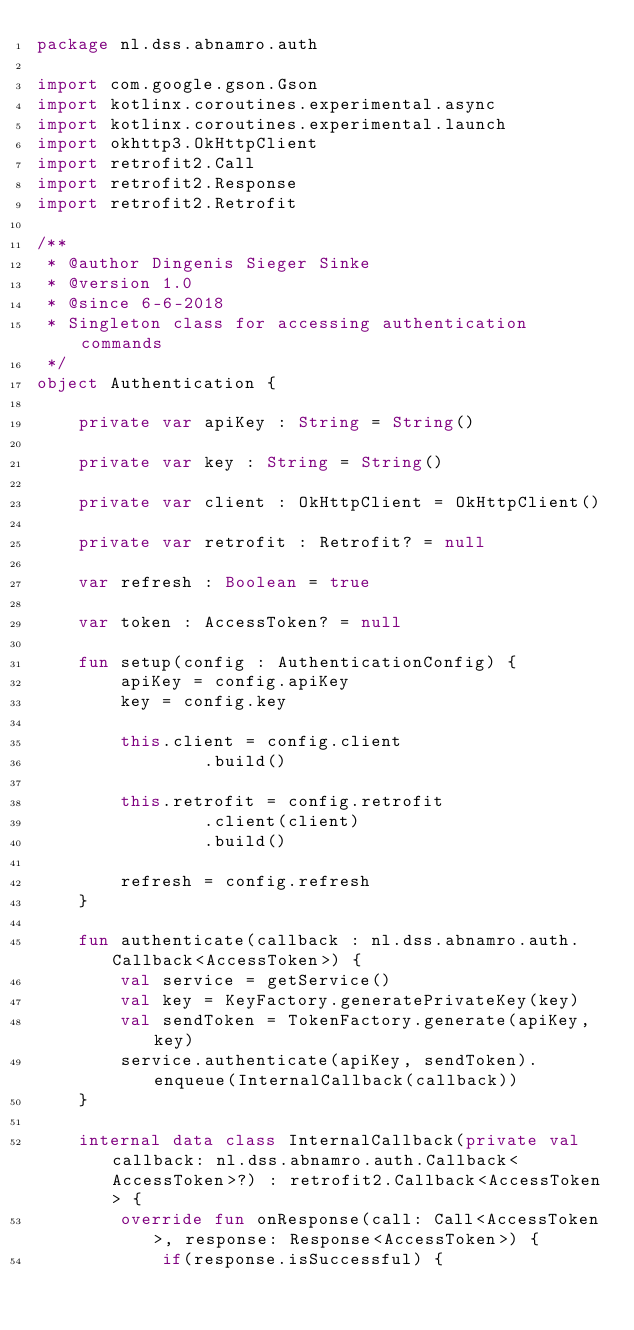Convert code to text. <code><loc_0><loc_0><loc_500><loc_500><_Kotlin_>package nl.dss.abnamro.auth

import com.google.gson.Gson
import kotlinx.coroutines.experimental.async
import kotlinx.coroutines.experimental.launch
import okhttp3.OkHttpClient
import retrofit2.Call
import retrofit2.Response
import retrofit2.Retrofit

/**
 * @author Dingenis Sieger Sinke
 * @version 1.0
 * @since 6-6-2018
 * Singleton class for accessing authentication commands
 */
object Authentication {

    private var apiKey : String = String()

    private var key : String = String()

    private var client : OkHttpClient = OkHttpClient()

    private var retrofit : Retrofit? = null

    var refresh : Boolean = true

    var token : AccessToken? = null

    fun setup(config : AuthenticationConfig) {
        apiKey = config.apiKey
        key = config.key

        this.client = config.client
                .build()

        this.retrofit = config.retrofit
                .client(client)
                .build()

        refresh = config.refresh
    }

    fun authenticate(callback : nl.dss.abnamro.auth.Callback<AccessToken>) {
        val service = getService()
        val key = KeyFactory.generatePrivateKey(key)
        val sendToken = TokenFactory.generate(apiKey, key)
        service.authenticate(apiKey, sendToken).enqueue(InternalCallback(callback))
    }

    internal data class InternalCallback(private val callback: nl.dss.abnamro.auth.Callback<AccessToken>?) : retrofit2.Callback<AccessToken> {
        override fun onResponse(call: Call<AccessToken>, response: Response<AccessToken>) {
            if(response.isSuccessful) {</code> 